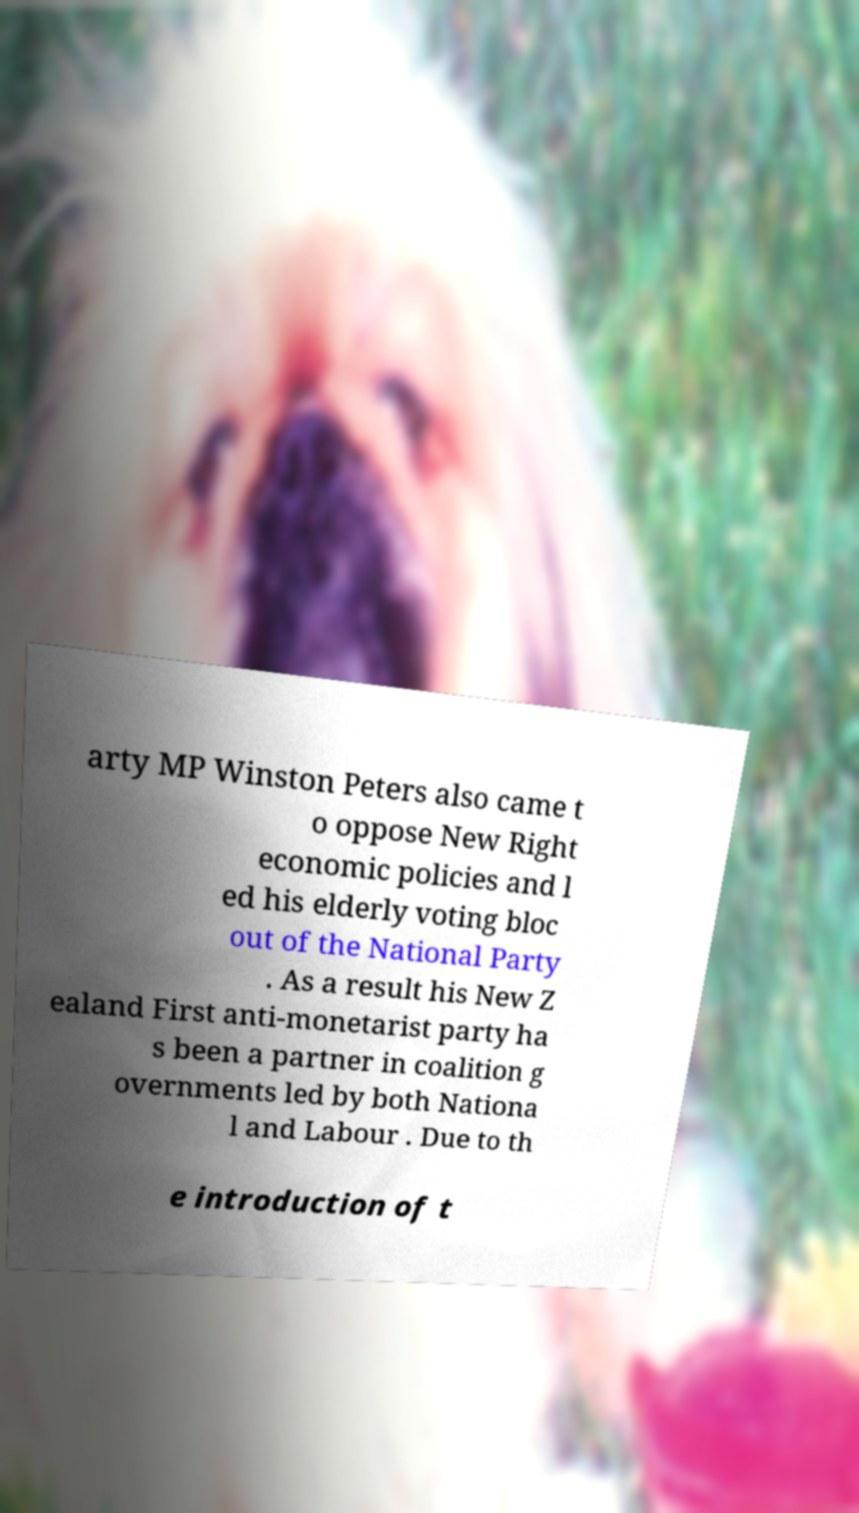Could you extract and type out the text from this image? arty MP Winston Peters also came t o oppose New Right economic policies and l ed his elderly voting bloc out of the National Party . As a result his New Z ealand First anti-monetarist party ha s been a partner in coalition g overnments led by both Nationa l and Labour . Due to th e introduction of t 